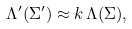Convert formula to latex. <formula><loc_0><loc_0><loc_500><loc_500>\Lambda ^ { \prime } ( { \Sigma } ^ { \prime } ) \approx k \, \Lambda ( { \Sigma } ) ,</formula> 